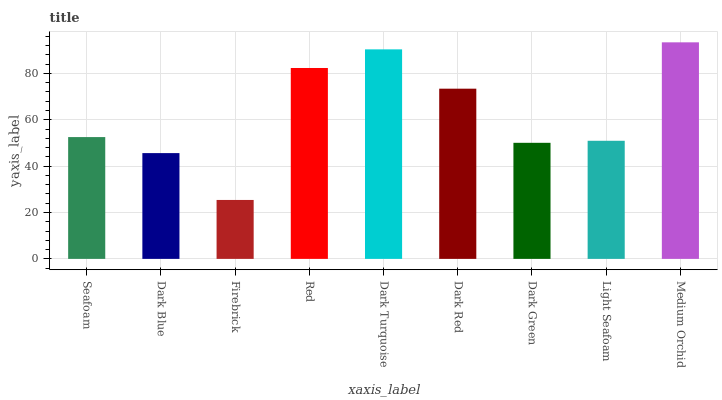Is Dark Blue the minimum?
Answer yes or no. No. Is Dark Blue the maximum?
Answer yes or no. No. Is Seafoam greater than Dark Blue?
Answer yes or no. Yes. Is Dark Blue less than Seafoam?
Answer yes or no. Yes. Is Dark Blue greater than Seafoam?
Answer yes or no. No. Is Seafoam less than Dark Blue?
Answer yes or no. No. Is Seafoam the high median?
Answer yes or no. Yes. Is Seafoam the low median?
Answer yes or no. Yes. Is Dark Turquoise the high median?
Answer yes or no. No. Is Light Seafoam the low median?
Answer yes or no. No. 